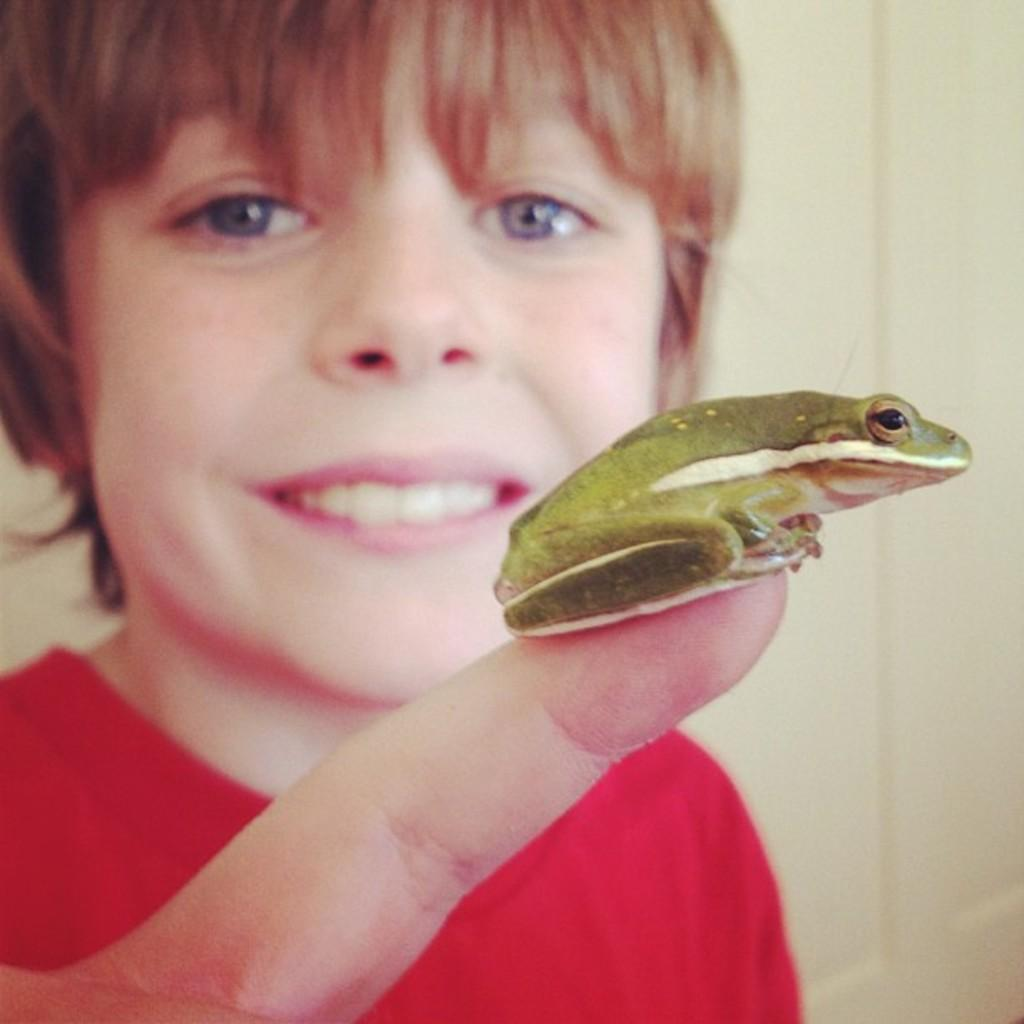What is the main subject in the front of the image? There is a frog in the front of the image. What is the person in the background of the image doing? The person is smiling in the background of the image. What can be seen on the right side of the image? There is a wall on the right side of the image. What type of question is the frog asking in the image? There is no indication that the frog is asking a question in the image. 